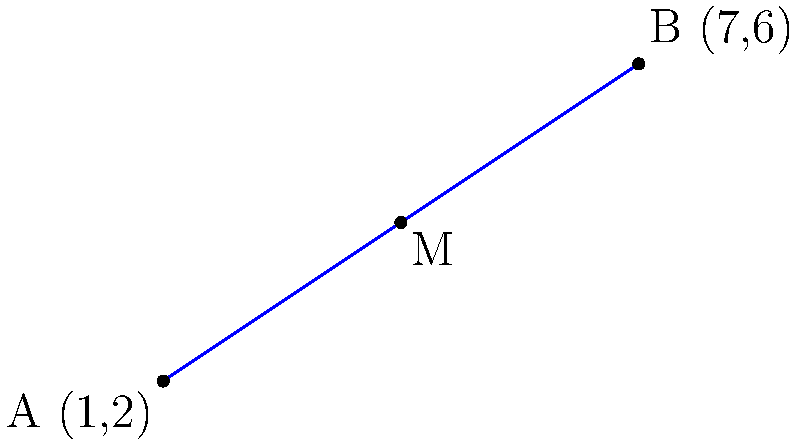In the coordinate plane above, points A and B are connected by a line segment. Without using a calculator, determine the coordinates of point M, which represents the midpoint of line segment AB. Express your answer as an ordered pair (x, y). To find the coordinates of the midpoint M of line segment AB, we can follow these steps:

1) Recall the midpoint formula: The coordinates of the midpoint are the averages of the x-coordinates and y-coordinates of the endpoints.

2) For a line segment with endpoints $(x_1, y_1)$ and $(x_2, y_2)$, the midpoint formula is:

   $M = (\frac{x_1 + x_2}{2}, \frac{y_1 + y_2}{2})$

3) In this case, we have:
   A $(x_1, y_1) = (1, 2)$
   B $(x_2, y_2) = (7, 6)$

4) Let's substitute these into our formula:

   $M = (\frac{1 + 7}{2}, \frac{2 + 6}{2})$

5) Now, let's simplify:
   $M = (\frac{8}{2}, \frac{8}{2})$

6) Simplify further:
   $M = (4, 4)$

Therefore, the coordinates of the midpoint M are (4, 4).
Answer: (4, 4) 